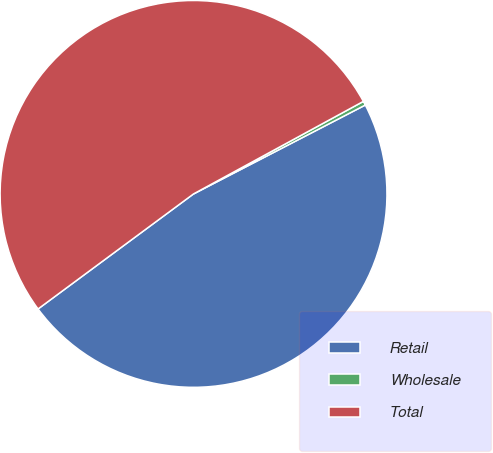Convert chart to OTSL. <chart><loc_0><loc_0><loc_500><loc_500><pie_chart><fcel>Retail<fcel>Wholesale<fcel>Total<nl><fcel>47.46%<fcel>0.34%<fcel>52.2%<nl></chart> 